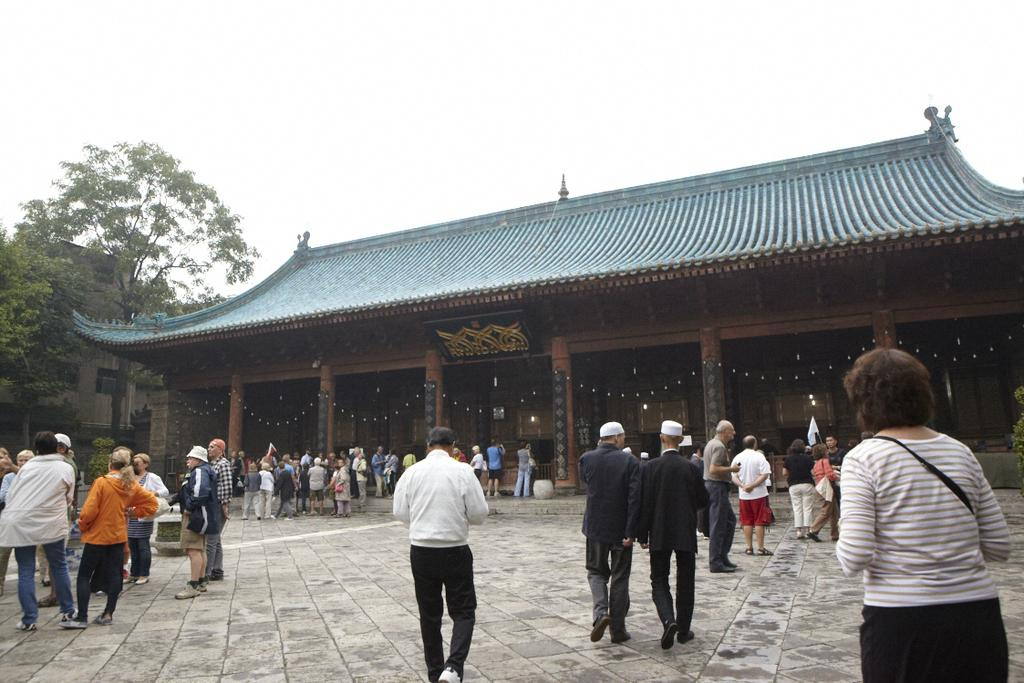What are the persons in the image doing? The persons in the image are on the floor. What can be seen in the background of the image? There are trees, buildings, and clouds in the sky in the background of the image. Can you see a sink in the image? There is no sink present in the image. Is there a tiger visible in the image? There is no tiger present in the image. 